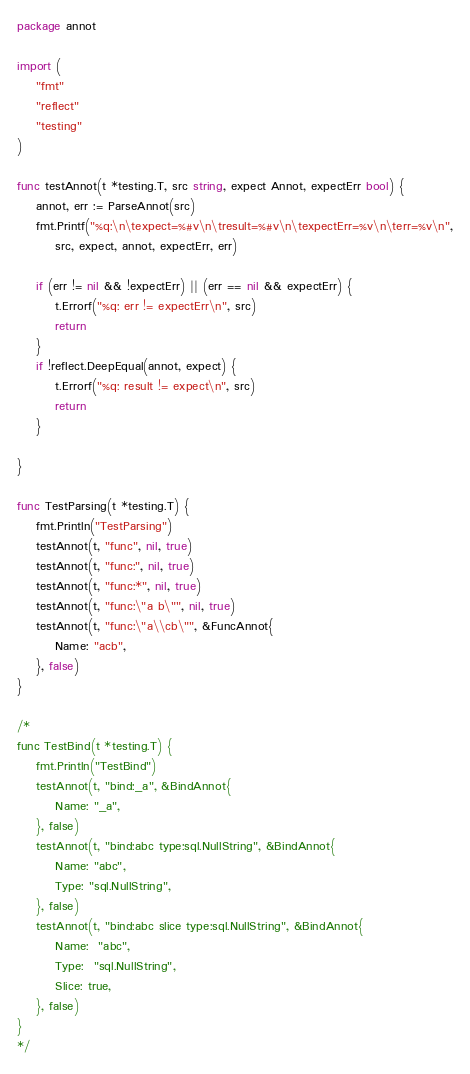<code> <loc_0><loc_0><loc_500><loc_500><_Go_>package annot

import (
	"fmt"
	"reflect"
	"testing"
)

func testAnnot(t *testing.T, src string, expect Annot, expectErr bool) {
	annot, err := ParseAnnot(src)
	fmt.Printf("%q:\n\texpect=%#v\n\tresult=%#v\n\texpectErr=%v\n\terr=%v\n",
		src, expect, annot, expectErr, err)

	if (err != nil && !expectErr) || (err == nil && expectErr) {
		t.Errorf("%q: err != expectErr\n", src)
		return
	}
	if !reflect.DeepEqual(annot, expect) {
		t.Errorf("%q: result != expect\n", src)
		return
	}

}

func TestParsing(t *testing.T) {
	fmt.Println("TestParsing")
	testAnnot(t, "func", nil, true)
	testAnnot(t, "func:", nil, true)
	testAnnot(t, "func:*", nil, true)
	testAnnot(t, "func:\"a b\"", nil, true)
	testAnnot(t, "func:\"a\\cb\"", &FuncAnnot{
		Name: "acb",
	}, false)
}

/*
func TestBind(t *testing.T) {
	fmt.Println("TestBind")
	testAnnot(t, "bind:_a", &BindAnnot{
		Name: "_a",
	}, false)
	testAnnot(t, "bind:abc type:sql.NullString", &BindAnnot{
		Name: "abc",
		Type: "sql.NullString",
	}, false)
	testAnnot(t, "bind:abc slice type:sql.NullString", &BindAnnot{
		Name:  "abc",
		Type:  "sql.NullString",
		Slice: true,
	}, false)
}
*/
</code> 